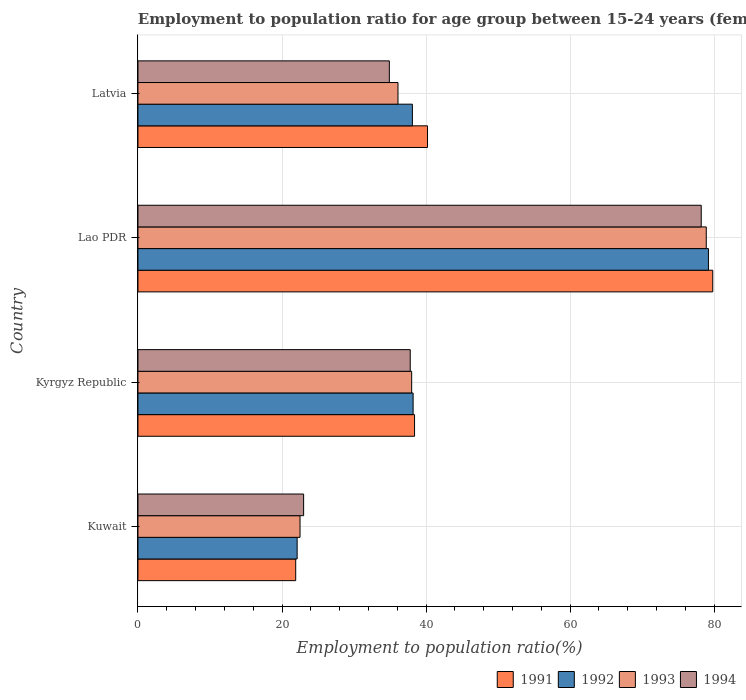How many groups of bars are there?
Give a very brief answer. 4. Are the number of bars per tick equal to the number of legend labels?
Offer a terse response. Yes. How many bars are there on the 2nd tick from the top?
Your response must be concise. 4. What is the label of the 3rd group of bars from the top?
Your response must be concise. Kyrgyz Republic. In how many cases, is the number of bars for a given country not equal to the number of legend labels?
Make the answer very short. 0. What is the employment to population ratio in 1993 in Lao PDR?
Ensure brevity in your answer.  78.9. Across all countries, what is the maximum employment to population ratio in 1992?
Keep it short and to the point. 79.2. In which country was the employment to population ratio in 1991 maximum?
Your answer should be compact. Lao PDR. In which country was the employment to population ratio in 1992 minimum?
Your answer should be compact. Kuwait. What is the total employment to population ratio in 1993 in the graph?
Provide a short and direct response. 175.5. What is the difference between the employment to population ratio in 1993 in Kyrgyz Republic and that in Latvia?
Your response must be concise. 1.9. What is the difference between the employment to population ratio in 1993 in Kuwait and the employment to population ratio in 1992 in Kyrgyz Republic?
Make the answer very short. -15.7. What is the average employment to population ratio in 1994 per country?
Your response must be concise. 43.47. What is the difference between the employment to population ratio in 1992 and employment to population ratio in 1993 in Kyrgyz Republic?
Give a very brief answer. 0.2. In how many countries, is the employment to population ratio in 1991 greater than 20 %?
Offer a terse response. 4. What is the ratio of the employment to population ratio in 1991 in Kuwait to that in Latvia?
Your answer should be compact. 0.54. Is the employment to population ratio in 1991 in Kuwait less than that in Lao PDR?
Keep it short and to the point. Yes. Is the difference between the employment to population ratio in 1992 in Kuwait and Lao PDR greater than the difference between the employment to population ratio in 1993 in Kuwait and Lao PDR?
Provide a succinct answer. No. What is the difference between the highest and the second highest employment to population ratio in 1993?
Make the answer very short. 40.9. What is the difference between the highest and the lowest employment to population ratio in 1991?
Your response must be concise. 57.9. What is the difference between two consecutive major ticks on the X-axis?
Your answer should be compact. 20. Does the graph contain any zero values?
Offer a terse response. No. Does the graph contain grids?
Give a very brief answer. Yes. How many legend labels are there?
Your answer should be compact. 4. How are the legend labels stacked?
Provide a short and direct response. Horizontal. What is the title of the graph?
Give a very brief answer. Employment to population ratio for age group between 15-24 years (females). Does "1997" appear as one of the legend labels in the graph?
Make the answer very short. No. What is the label or title of the X-axis?
Make the answer very short. Employment to population ratio(%). What is the label or title of the Y-axis?
Your response must be concise. Country. What is the Employment to population ratio(%) of 1991 in Kuwait?
Offer a very short reply. 21.9. What is the Employment to population ratio(%) in 1992 in Kuwait?
Make the answer very short. 22.1. What is the Employment to population ratio(%) in 1994 in Kuwait?
Provide a succinct answer. 23. What is the Employment to population ratio(%) in 1991 in Kyrgyz Republic?
Offer a terse response. 38.4. What is the Employment to population ratio(%) of 1992 in Kyrgyz Republic?
Give a very brief answer. 38.2. What is the Employment to population ratio(%) of 1994 in Kyrgyz Republic?
Keep it short and to the point. 37.8. What is the Employment to population ratio(%) of 1991 in Lao PDR?
Offer a terse response. 79.8. What is the Employment to population ratio(%) of 1992 in Lao PDR?
Offer a very short reply. 79.2. What is the Employment to population ratio(%) of 1993 in Lao PDR?
Your response must be concise. 78.9. What is the Employment to population ratio(%) in 1994 in Lao PDR?
Provide a succinct answer. 78.2. What is the Employment to population ratio(%) in 1991 in Latvia?
Provide a succinct answer. 40.2. What is the Employment to population ratio(%) in 1992 in Latvia?
Provide a short and direct response. 38.1. What is the Employment to population ratio(%) in 1993 in Latvia?
Ensure brevity in your answer.  36.1. What is the Employment to population ratio(%) in 1994 in Latvia?
Make the answer very short. 34.9. Across all countries, what is the maximum Employment to population ratio(%) in 1991?
Give a very brief answer. 79.8. Across all countries, what is the maximum Employment to population ratio(%) of 1992?
Your response must be concise. 79.2. Across all countries, what is the maximum Employment to population ratio(%) in 1993?
Keep it short and to the point. 78.9. Across all countries, what is the maximum Employment to population ratio(%) of 1994?
Offer a terse response. 78.2. Across all countries, what is the minimum Employment to population ratio(%) of 1991?
Your response must be concise. 21.9. Across all countries, what is the minimum Employment to population ratio(%) in 1992?
Provide a succinct answer. 22.1. What is the total Employment to population ratio(%) of 1991 in the graph?
Provide a succinct answer. 180.3. What is the total Employment to population ratio(%) of 1992 in the graph?
Make the answer very short. 177.6. What is the total Employment to population ratio(%) of 1993 in the graph?
Make the answer very short. 175.5. What is the total Employment to population ratio(%) of 1994 in the graph?
Keep it short and to the point. 173.9. What is the difference between the Employment to population ratio(%) of 1991 in Kuwait and that in Kyrgyz Republic?
Make the answer very short. -16.5. What is the difference between the Employment to population ratio(%) of 1992 in Kuwait and that in Kyrgyz Republic?
Offer a terse response. -16.1. What is the difference between the Employment to population ratio(%) in 1993 in Kuwait and that in Kyrgyz Republic?
Provide a succinct answer. -15.5. What is the difference between the Employment to population ratio(%) of 1994 in Kuwait and that in Kyrgyz Republic?
Your response must be concise. -14.8. What is the difference between the Employment to population ratio(%) of 1991 in Kuwait and that in Lao PDR?
Your response must be concise. -57.9. What is the difference between the Employment to population ratio(%) in 1992 in Kuwait and that in Lao PDR?
Make the answer very short. -57.1. What is the difference between the Employment to population ratio(%) in 1993 in Kuwait and that in Lao PDR?
Make the answer very short. -56.4. What is the difference between the Employment to population ratio(%) of 1994 in Kuwait and that in Lao PDR?
Make the answer very short. -55.2. What is the difference between the Employment to population ratio(%) in 1991 in Kuwait and that in Latvia?
Ensure brevity in your answer.  -18.3. What is the difference between the Employment to population ratio(%) in 1992 in Kuwait and that in Latvia?
Offer a very short reply. -16. What is the difference between the Employment to population ratio(%) of 1994 in Kuwait and that in Latvia?
Keep it short and to the point. -11.9. What is the difference between the Employment to population ratio(%) of 1991 in Kyrgyz Republic and that in Lao PDR?
Your answer should be compact. -41.4. What is the difference between the Employment to population ratio(%) in 1992 in Kyrgyz Republic and that in Lao PDR?
Ensure brevity in your answer.  -41. What is the difference between the Employment to population ratio(%) in 1993 in Kyrgyz Republic and that in Lao PDR?
Make the answer very short. -40.9. What is the difference between the Employment to population ratio(%) in 1994 in Kyrgyz Republic and that in Lao PDR?
Provide a short and direct response. -40.4. What is the difference between the Employment to population ratio(%) in 1992 in Kyrgyz Republic and that in Latvia?
Offer a terse response. 0.1. What is the difference between the Employment to population ratio(%) in 1991 in Lao PDR and that in Latvia?
Provide a succinct answer. 39.6. What is the difference between the Employment to population ratio(%) in 1992 in Lao PDR and that in Latvia?
Keep it short and to the point. 41.1. What is the difference between the Employment to population ratio(%) in 1993 in Lao PDR and that in Latvia?
Your answer should be very brief. 42.8. What is the difference between the Employment to population ratio(%) of 1994 in Lao PDR and that in Latvia?
Ensure brevity in your answer.  43.3. What is the difference between the Employment to population ratio(%) in 1991 in Kuwait and the Employment to population ratio(%) in 1992 in Kyrgyz Republic?
Provide a succinct answer. -16.3. What is the difference between the Employment to population ratio(%) in 1991 in Kuwait and the Employment to population ratio(%) in 1993 in Kyrgyz Republic?
Your answer should be compact. -16.1. What is the difference between the Employment to population ratio(%) of 1991 in Kuwait and the Employment to population ratio(%) of 1994 in Kyrgyz Republic?
Provide a succinct answer. -15.9. What is the difference between the Employment to population ratio(%) in 1992 in Kuwait and the Employment to population ratio(%) in 1993 in Kyrgyz Republic?
Your answer should be very brief. -15.9. What is the difference between the Employment to population ratio(%) in 1992 in Kuwait and the Employment to population ratio(%) in 1994 in Kyrgyz Republic?
Give a very brief answer. -15.7. What is the difference between the Employment to population ratio(%) in 1993 in Kuwait and the Employment to population ratio(%) in 1994 in Kyrgyz Republic?
Offer a terse response. -15.3. What is the difference between the Employment to population ratio(%) of 1991 in Kuwait and the Employment to population ratio(%) of 1992 in Lao PDR?
Provide a short and direct response. -57.3. What is the difference between the Employment to population ratio(%) in 1991 in Kuwait and the Employment to population ratio(%) in 1993 in Lao PDR?
Your answer should be compact. -57. What is the difference between the Employment to population ratio(%) of 1991 in Kuwait and the Employment to population ratio(%) of 1994 in Lao PDR?
Ensure brevity in your answer.  -56.3. What is the difference between the Employment to population ratio(%) of 1992 in Kuwait and the Employment to population ratio(%) of 1993 in Lao PDR?
Provide a short and direct response. -56.8. What is the difference between the Employment to population ratio(%) in 1992 in Kuwait and the Employment to population ratio(%) in 1994 in Lao PDR?
Provide a succinct answer. -56.1. What is the difference between the Employment to population ratio(%) of 1993 in Kuwait and the Employment to population ratio(%) of 1994 in Lao PDR?
Provide a succinct answer. -55.7. What is the difference between the Employment to population ratio(%) of 1991 in Kuwait and the Employment to population ratio(%) of 1992 in Latvia?
Offer a very short reply. -16.2. What is the difference between the Employment to population ratio(%) of 1992 in Kuwait and the Employment to population ratio(%) of 1994 in Latvia?
Your answer should be compact. -12.8. What is the difference between the Employment to population ratio(%) of 1991 in Kyrgyz Republic and the Employment to population ratio(%) of 1992 in Lao PDR?
Ensure brevity in your answer.  -40.8. What is the difference between the Employment to population ratio(%) of 1991 in Kyrgyz Republic and the Employment to population ratio(%) of 1993 in Lao PDR?
Offer a terse response. -40.5. What is the difference between the Employment to population ratio(%) of 1991 in Kyrgyz Republic and the Employment to population ratio(%) of 1994 in Lao PDR?
Offer a very short reply. -39.8. What is the difference between the Employment to population ratio(%) of 1992 in Kyrgyz Republic and the Employment to population ratio(%) of 1993 in Lao PDR?
Provide a succinct answer. -40.7. What is the difference between the Employment to population ratio(%) in 1993 in Kyrgyz Republic and the Employment to population ratio(%) in 1994 in Lao PDR?
Make the answer very short. -40.2. What is the difference between the Employment to population ratio(%) of 1991 in Kyrgyz Republic and the Employment to population ratio(%) of 1992 in Latvia?
Your response must be concise. 0.3. What is the difference between the Employment to population ratio(%) of 1991 in Lao PDR and the Employment to population ratio(%) of 1992 in Latvia?
Provide a succinct answer. 41.7. What is the difference between the Employment to population ratio(%) in 1991 in Lao PDR and the Employment to population ratio(%) in 1993 in Latvia?
Your answer should be very brief. 43.7. What is the difference between the Employment to population ratio(%) in 1991 in Lao PDR and the Employment to population ratio(%) in 1994 in Latvia?
Give a very brief answer. 44.9. What is the difference between the Employment to population ratio(%) in 1992 in Lao PDR and the Employment to population ratio(%) in 1993 in Latvia?
Your answer should be compact. 43.1. What is the difference between the Employment to population ratio(%) in 1992 in Lao PDR and the Employment to population ratio(%) in 1994 in Latvia?
Give a very brief answer. 44.3. What is the average Employment to population ratio(%) in 1991 per country?
Make the answer very short. 45.08. What is the average Employment to population ratio(%) of 1992 per country?
Your answer should be compact. 44.4. What is the average Employment to population ratio(%) of 1993 per country?
Give a very brief answer. 43.88. What is the average Employment to population ratio(%) in 1994 per country?
Offer a very short reply. 43.48. What is the difference between the Employment to population ratio(%) in 1991 and Employment to population ratio(%) in 1992 in Kuwait?
Provide a short and direct response. -0.2. What is the difference between the Employment to population ratio(%) of 1992 and Employment to population ratio(%) of 1994 in Kuwait?
Give a very brief answer. -0.9. What is the difference between the Employment to population ratio(%) of 1991 and Employment to population ratio(%) of 1994 in Kyrgyz Republic?
Give a very brief answer. 0.6. What is the difference between the Employment to population ratio(%) in 1991 and Employment to population ratio(%) in 1992 in Lao PDR?
Offer a terse response. 0.6. What is the difference between the Employment to population ratio(%) of 1991 and Employment to population ratio(%) of 1993 in Lao PDR?
Your answer should be compact. 0.9. What is the difference between the Employment to population ratio(%) of 1991 and Employment to population ratio(%) of 1994 in Lao PDR?
Offer a very short reply. 1.6. What is the difference between the Employment to population ratio(%) in 1992 and Employment to population ratio(%) in 1993 in Lao PDR?
Provide a succinct answer. 0.3. What is the difference between the Employment to population ratio(%) in 1992 and Employment to population ratio(%) in 1994 in Lao PDR?
Your answer should be very brief. 1. What is the difference between the Employment to population ratio(%) of 1993 and Employment to population ratio(%) of 1994 in Lao PDR?
Make the answer very short. 0.7. What is the difference between the Employment to population ratio(%) of 1991 and Employment to population ratio(%) of 1993 in Latvia?
Ensure brevity in your answer.  4.1. What is the difference between the Employment to population ratio(%) in 1991 and Employment to population ratio(%) in 1994 in Latvia?
Your response must be concise. 5.3. What is the difference between the Employment to population ratio(%) of 1992 and Employment to population ratio(%) of 1994 in Latvia?
Provide a succinct answer. 3.2. What is the difference between the Employment to population ratio(%) of 1993 and Employment to population ratio(%) of 1994 in Latvia?
Offer a terse response. 1.2. What is the ratio of the Employment to population ratio(%) in 1991 in Kuwait to that in Kyrgyz Republic?
Make the answer very short. 0.57. What is the ratio of the Employment to population ratio(%) in 1992 in Kuwait to that in Kyrgyz Republic?
Keep it short and to the point. 0.58. What is the ratio of the Employment to population ratio(%) of 1993 in Kuwait to that in Kyrgyz Republic?
Your answer should be very brief. 0.59. What is the ratio of the Employment to population ratio(%) of 1994 in Kuwait to that in Kyrgyz Republic?
Give a very brief answer. 0.61. What is the ratio of the Employment to population ratio(%) in 1991 in Kuwait to that in Lao PDR?
Your response must be concise. 0.27. What is the ratio of the Employment to population ratio(%) of 1992 in Kuwait to that in Lao PDR?
Offer a very short reply. 0.28. What is the ratio of the Employment to population ratio(%) in 1993 in Kuwait to that in Lao PDR?
Offer a very short reply. 0.29. What is the ratio of the Employment to population ratio(%) in 1994 in Kuwait to that in Lao PDR?
Offer a very short reply. 0.29. What is the ratio of the Employment to population ratio(%) of 1991 in Kuwait to that in Latvia?
Offer a very short reply. 0.54. What is the ratio of the Employment to population ratio(%) in 1992 in Kuwait to that in Latvia?
Keep it short and to the point. 0.58. What is the ratio of the Employment to population ratio(%) of 1993 in Kuwait to that in Latvia?
Give a very brief answer. 0.62. What is the ratio of the Employment to population ratio(%) in 1994 in Kuwait to that in Latvia?
Offer a very short reply. 0.66. What is the ratio of the Employment to population ratio(%) of 1991 in Kyrgyz Republic to that in Lao PDR?
Provide a short and direct response. 0.48. What is the ratio of the Employment to population ratio(%) of 1992 in Kyrgyz Republic to that in Lao PDR?
Your answer should be compact. 0.48. What is the ratio of the Employment to population ratio(%) in 1993 in Kyrgyz Republic to that in Lao PDR?
Make the answer very short. 0.48. What is the ratio of the Employment to population ratio(%) in 1994 in Kyrgyz Republic to that in Lao PDR?
Ensure brevity in your answer.  0.48. What is the ratio of the Employment to population ratio(%) of 1991 in Kyrgyz Republic to that in Latvia?
Ensure brevity in your answer.  0.96. What is the ratio of the Employment to population ratio(%) in 1993 in Kyrgyz Republic to that in Latvia?
Provide a short and direct response. 1.05. What is the ratio of the Employment to population ratio(%) in 1994 in Kyrgyz Republic to that in Latvia?
Offer a terse response. 1.08. What is the ratio of the Employment to population ratio(%) in 1991 in Lao PDR to that in Latvia?
Offer a terse response. 1.99. What is the ratio of the Employment to population ratio(%) of 1992 in Lao PDR to that in Latvia?
Your response must be concise. 2.08. What is the ratio of the Employment to population ratio(%) in 1993 in Lao PDR to that in Latvia?
Your answer should be very brief. 2.19. What is the ratio of the Employment to population ratio(%) in 1994 in Lao PDR to that in Latvia?
Offer a terse response. 2.24. What is the difference between the highest and the second highest Employment to population ratio(%) of 1991?
Your answer should be compact. 39.6. What is the difference between the highest and the second highest Employment to population ratio(%) in 1992?
Your response must be concise. 41. What is the difference between the highest and the second highest Employment to population ratio(%) of 1993?
Your answer should be compact. 40.9. What is the difference between the highest and the second highest Employment to population ratio(%) in 1994?
Offer a very short reply. 40.4. What is the difference between the highest and the lowest Employment to population ratio(%) in 1991?
Your response must be concise. 57.9. What is the difference between the highest and the lowest Employment to population ratio(%) of 1992?
Provide a short and direct response. 57.1. What is the difference between the highest and the lowest Employment to population ratio(%) in 1993?
Offer a terse response. 56.4. What is the difference between the highest and the lowest Employment to population ratio(%) of 1994?
Your response must be concise. 55.2. 